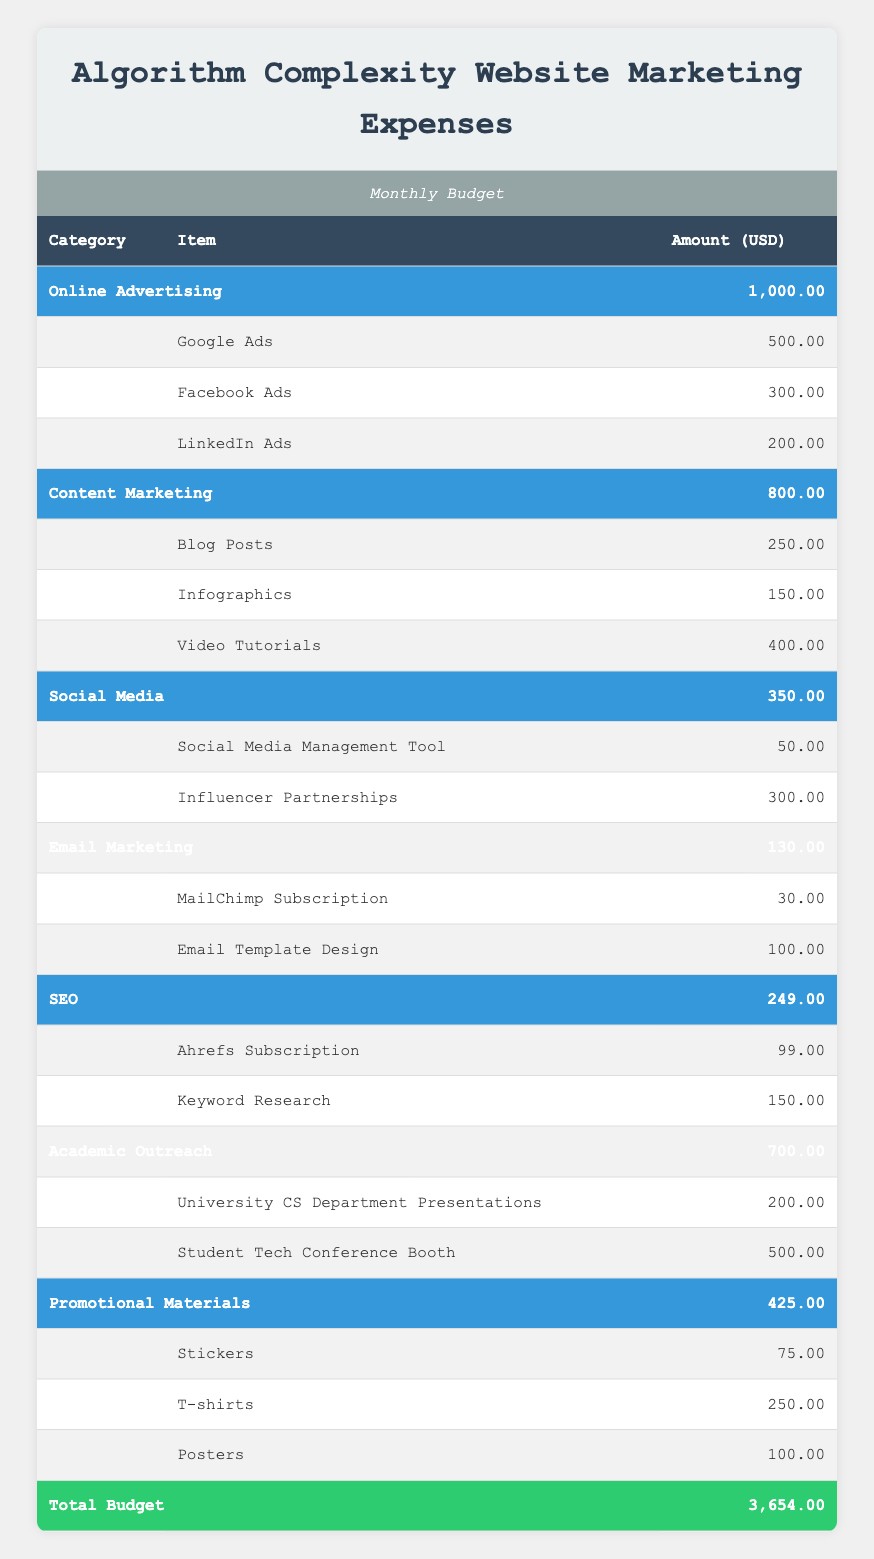What is the total amount spent on Online Advertising? The Online Advertising category has three items: Google Ads (500.00), Facebook Ads (300.00), and LinkedIn Ads (200.00). To find the total, we add these amounts: 500.00 + 300.00 + 200.00 = 1000.00.
Answer: 1000.00 How much was spent on Content Marketing compared to Social Media? The Content Marketing category total is 800.00, which includes Blog Posts (250.00), Infographics (150.00), and Video Tutorials (400.00). The Social Media category total is 350.00, from Social Media Management Tool (50.00) and Influencer Partnerships (300.00). The difference is 800.00 - 350.00 = 450.00.
Answer: 450.00 Is the total amount spent on SEO greater than 200? The total for SEO is 249.00, which is clearly above 200. Therefore, the statement is true.
Answer: Yes What percentage of the total budget does Academic Outreach represent? The Academic Outreach category has a total of 700.00, and the total budget is 3654.00. To find the percentage, we calculate (700.00 / 3654.00) * 100, which gives approximately 19.17%.
Answer: 19.17% What is the combined amount spent on Promotional Materials and Email Marketing? The total for Promotional Materials is 425.00 (Stickers at 75.00, T-shirts at 250.00, Posters at 100.00) and Email Marketing is 130.00 (MailChimp Subscription at 30.00, Email Template Design at 100.00). Adding these together gives 425.00 + 130.00 = 555.00.
Answer: 555.00 Which item in the Content Marketing category has the highest expense? In the Content Marketing category, the expenses are Blog Posts (250.00), Infographics (150.00), and Video Tutorials (400.00). The Video Tutorials have the highest expense at 400.00.
Answer: Video Tutorials How much more was spent on Google Ads compared to MailChimp Subscription? Google Ads costs 500.00, and MailChimp Subscription costs 30.00. The difference is calculated as 500.00 - 30.00 = 470.00, indicating that 470.00 more was spent on Google Ads.
Answer: 470.00 Does the total expense for Social Media exceed that for Email Marketing? The total for Social Media is 350.00, and for Email Marketing, it is 130.00. Since 350.00 is greater than 130.00, the statement is true.
Answer: Yes What is the average expense for items in the Promotional Materials category? Promotional Materials has three items: Stickers (75.00), T-shirts (250.00), and Posters (100.00). To find the average, we first sum the amounts: 75.00 + 250.00 + 100.00 = 425.00. We divide by the number of items, which is 3: 425.00 / 3 = 141.67.
Answer: 141.67 